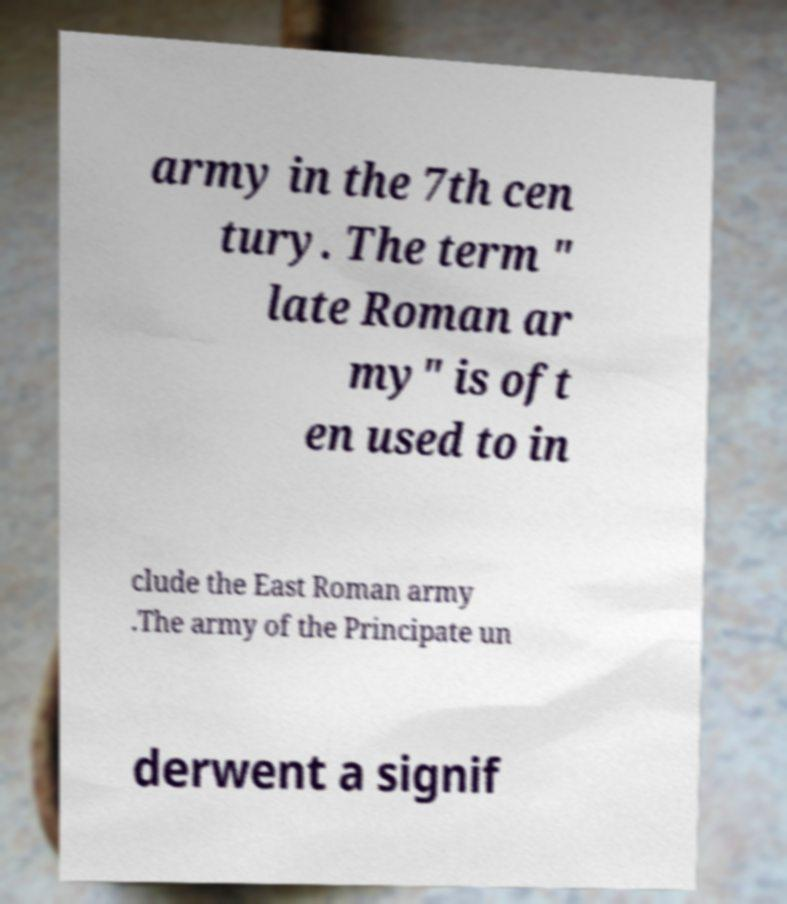Please read and relay the text visible in this image. What does it say? army in the 7th cen tury. The term " late Roman ar my" is oft en used to in clude the East Roman army .The army of the Principate un derwent a signif 